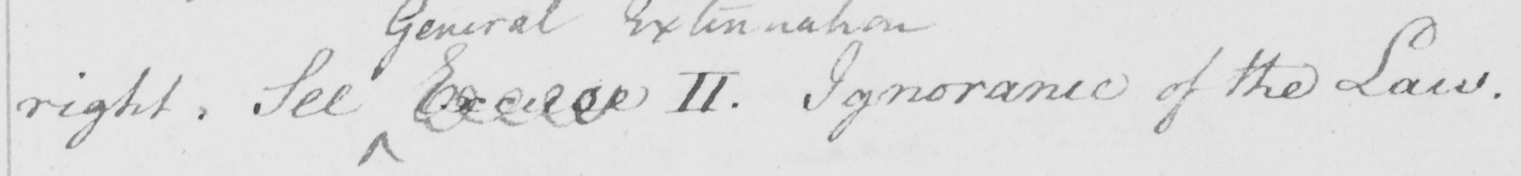Transcribe the text shown in this historical manuscript line. right. See Excuse II. Ignorance of the Law. 